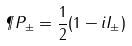<formula> <loc_0><loc_0><loc_500><loc_500>\P P _ { \pm } = \frac { 1 } { 2 } ( 1 - i I _ { \pm } )</formula> 